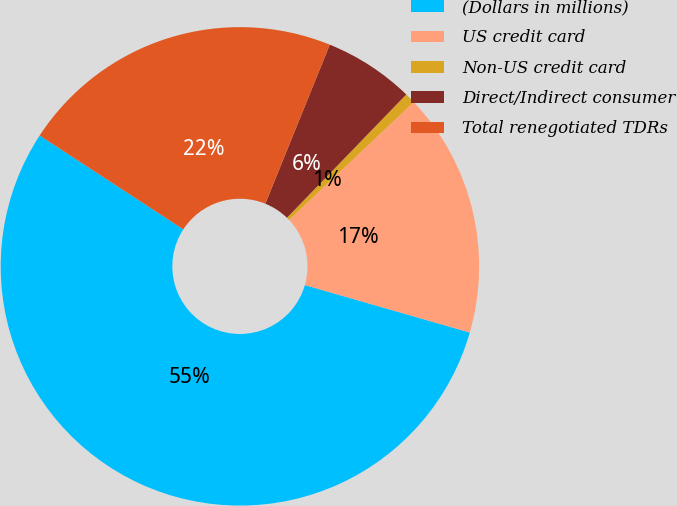Convert chart to OTSL. <chart><loc_0><loc_0><loc_500><loc_500><pie_chart><fcel>(Dollars in millions)<fcel>US credit card<fcel>Non-US credit card<fcel>Direct/Indirect consumer<fcel>Total renegotiated TDRs<nl><fcel>54.75%<fcel>16.51%<fcel>0.71%<fcel>6.11%<fcel>21.92%<nl></chart> 